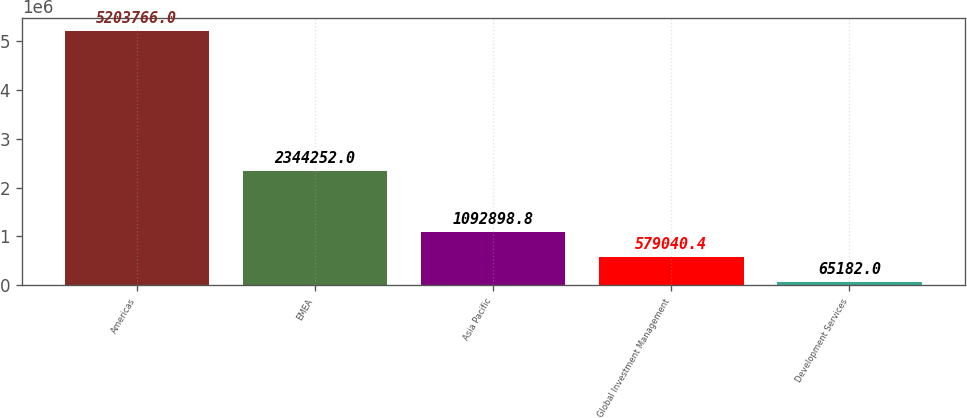Convert chart to OTSL. <chart><loc_0><loc_0><loc_500><loc_500><bar_chart><fcel>Americas<fcel>EMEA<fcel>Asia Pacific<fcel>Global Investment Management<fcel>Development Services<nl><fcel>5.20377e+06<fcel>2.34425e+06<fcel>1.0929e+06<fcel>579040<fcel>65182<nl></chart> 